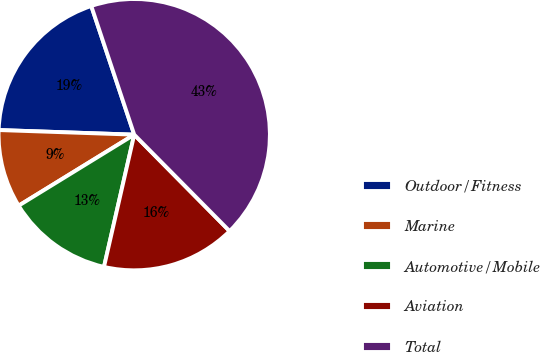Convert chart to OTSL. <chart><loc_0><loc_0><loc_500><loc_500><pie_chart><fcel>Outdoor/Fitness<fcel>Marine<fcel>Automotive/Mobile<fcel>Aviation<fcel>Total<nl><fcel>19.33%<fcel>9.31%<fcel>12.65%<fcel>15.99%<fcel>42.71%<nl></chart> 